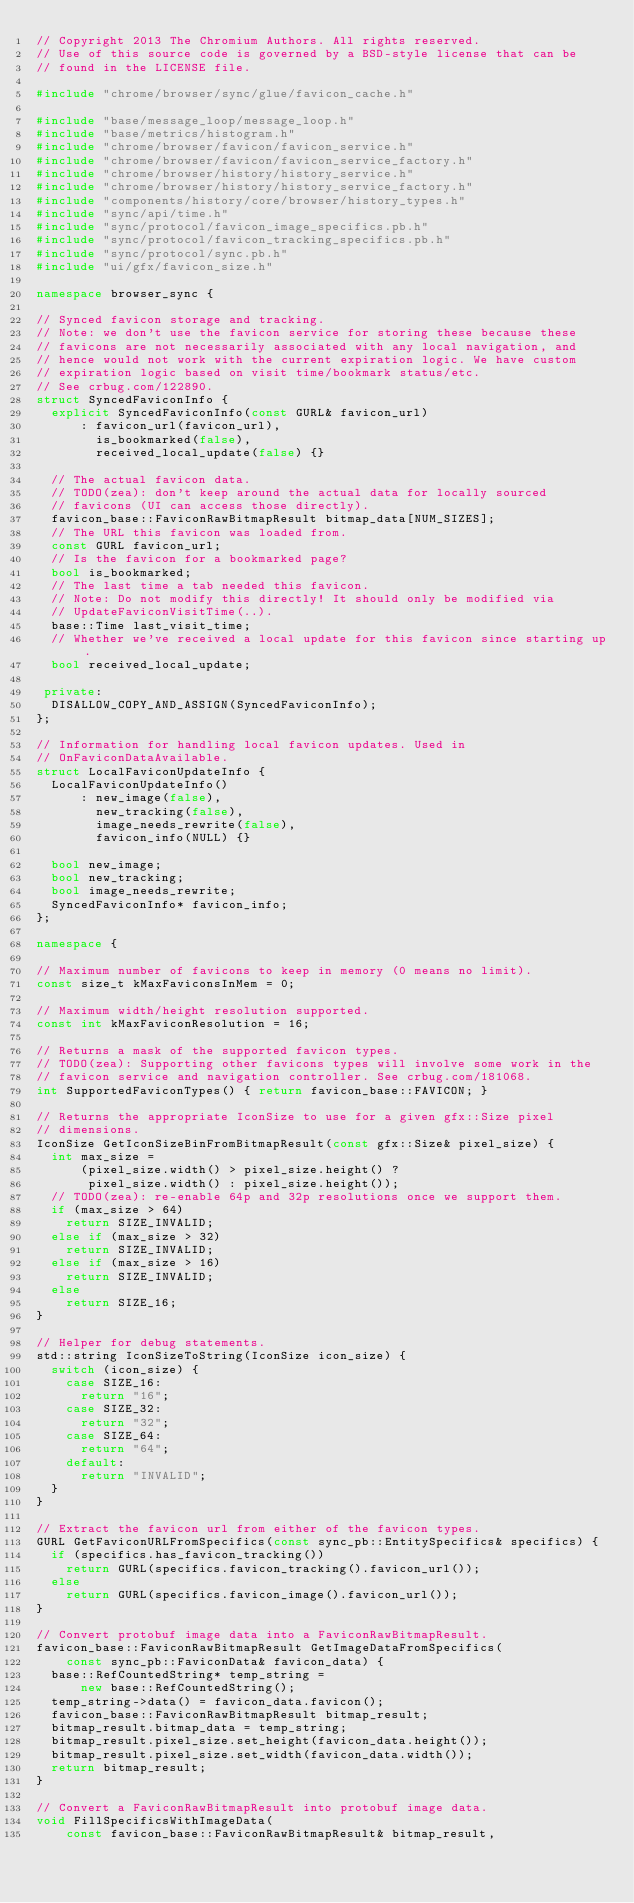<code> <loc_0><loc_0><loc_500><loc_500><_C++_>// Copyright 2013 The Chromium Authors. All rights reserved.
// Use of this source code is governed by a BSD-style license that can be
// found in the LICENSE file.

#include "chrome/browser/sync/glue/favicon_cache.h"

#include "base/message_loop/message_loop.h"
#include "base/metrics/histogram.h"
#include "chrome/browser/favicon/favicon_service.h"
#include "chrome/browser/favicon/favicon_service_factory.h"
#include "chrome/browser/history/history_service.h"
#include "chrome/browser/history/history_service_factory.h"
#include "components/history/core/browser/history_types.h"
#include "sync/api/time.h"
#include "sync/protocol/favicon_image_specifics.pb.h"
#include "sync/protocol/favicon_tracking_specifics.pb.h"
#include "sync/protocol/sync.pb.h"
#include "ui/gfx/favicon_size.h"

namespace browser_sync {

// Synced favicon storage and tracking.
// Note: we don't use the favicon service for storing these because these
// favicons are not necessarily associated with any local navigation, and
// hence would not work with the current expiration logic. We have custom
// expiration logic based on visit time/bookmark status/etc.
// See crbug.com/122890.
struct SyncedFaviconInfo {
  explicit SyncedFaviconInfo(const GURL& favicon_url)
      : favicon_url(favicon_url),
        is_bookmarked(false),
        received_local_update(false) {}

  // The actual favicon data.
  // TODO(zea): don't keep around the actual data for locally sourced
  // favicons (UI can access those directly).
  favicon_base::FaviconRawBitmapResult bitmap_data[NUM_SIZES];
  // The URL this favicon was loaded from.
  const GURL favicon_url;
  // Is the favicon for a bookmarked page?
  bool is_bookmarked;
  // The last time a tab needed this favicon.
  // Note: Do not modify this directly! It should only be modified via
  // UpdateFaviconVisitTime(..).
  base::Time last_visit_time;
  // Whether we've received a local update for this favicon since starting up.
  bool received_local_update;

 private:
  DISALLOW_COPY_AND_ASSIGN(SyncedFaviconInfo);
};

// Information for handling local favicon updates. Used in
// OnFaviconDataAvailable.
struct LocalFaviconUpdateInfo {
  LocalFaviconUpdateInfo()
      : new_image(false),
        new_tracking(false),
        image_needs_rewrite(false),
        favicon_info(NULL) {}

  bool new_image;
  bool new_tracking;
  bool image_needs_rewrite;
  SyncedFaviconInfo* favicon_info;
};

namespace {

// Maximum number of favicons to keep in memory (0 means no limit).
const size_t kMaxFaviconsInMem = 0;

// Maximum width/height resolution supported.
const int kMaxFaviconResolution = 16;

// Returns a mask of the supported favicon types.
// TODO(zea): Supporting other favicons types will involve some work in the
// favicon service and navigation controller. See crbug.com/181068.
int SupportedFaviconTypes() { return favicon_base::FAVICON; }

// Returns the appropriate IconSize to use for a given gfx::Size pixel
// dimensions.
IconSize GetIconSizeBinFromBitmapResult(const gfx::Size& pixel_size) {
  int max_size =
      (pixel_size.width() > pixel_size.height() ?
       pixel_size.width() : pixel_size.height());
  // TODO(zea): re-enable 64p and 32p resolutions once we support them.
  if (max_size > 64)
    return SIZE_INVALID;
  else if (max_size > 32)
    return SIZE_INVALID;
  else if (max_size > 16)
    return SIZE_INVALID;
  else
    return SIZE_16;
}

// Helper for debug statements.
std::string IconSizeToString(IconSize icon_size) {
  switch (icon_size) {
    case SIZE_16:
      return "16";
    case SIZE_32:
      return "32";
    case SIZE_64:
      return "64";
    default:
      return "INVALID";
  }
}

// Extract the favicon url from either of the favicon types.
GURL GetFaviconURLFromSpecifics(const sync_pb::EntitySpecifics& specifics) {
  if (specifics.has_favicon_tracking())
    return GURL(specifics.favicon_tracking().favicon_url());
  else
    return GURL(specifics.favicon_image().favicon_url());
}

// Convert protobuf image data into a FaviconRawBitmapResult.
favicon_base::FaviconRawBitmapResult GetImageDataFromSpecifics(
    const sync_pb::FaviconData& favicon_data) {
  base::RefCountedString* temp_string =
      new base::RefCountedString();
  temp_string->data() = favicon_data.favicon();
  favicon_base::FaviconRawBitmapResult bitmap_result;
  bitmap_result.bitmap_data = temp_string;
  bitmap_result.pixel_size.set_height(favicon_data.height());
  bitmap_result.pixel_size.set_width(favicon_data.width());
  return bitmap_result;
}

// Convert a FaviconRawBitmapResult into protobuf image data.
void FillSpecificsWithImageData(
    const favicon_base::FaviconRawBitmapResult& bitmap_result,</code> 